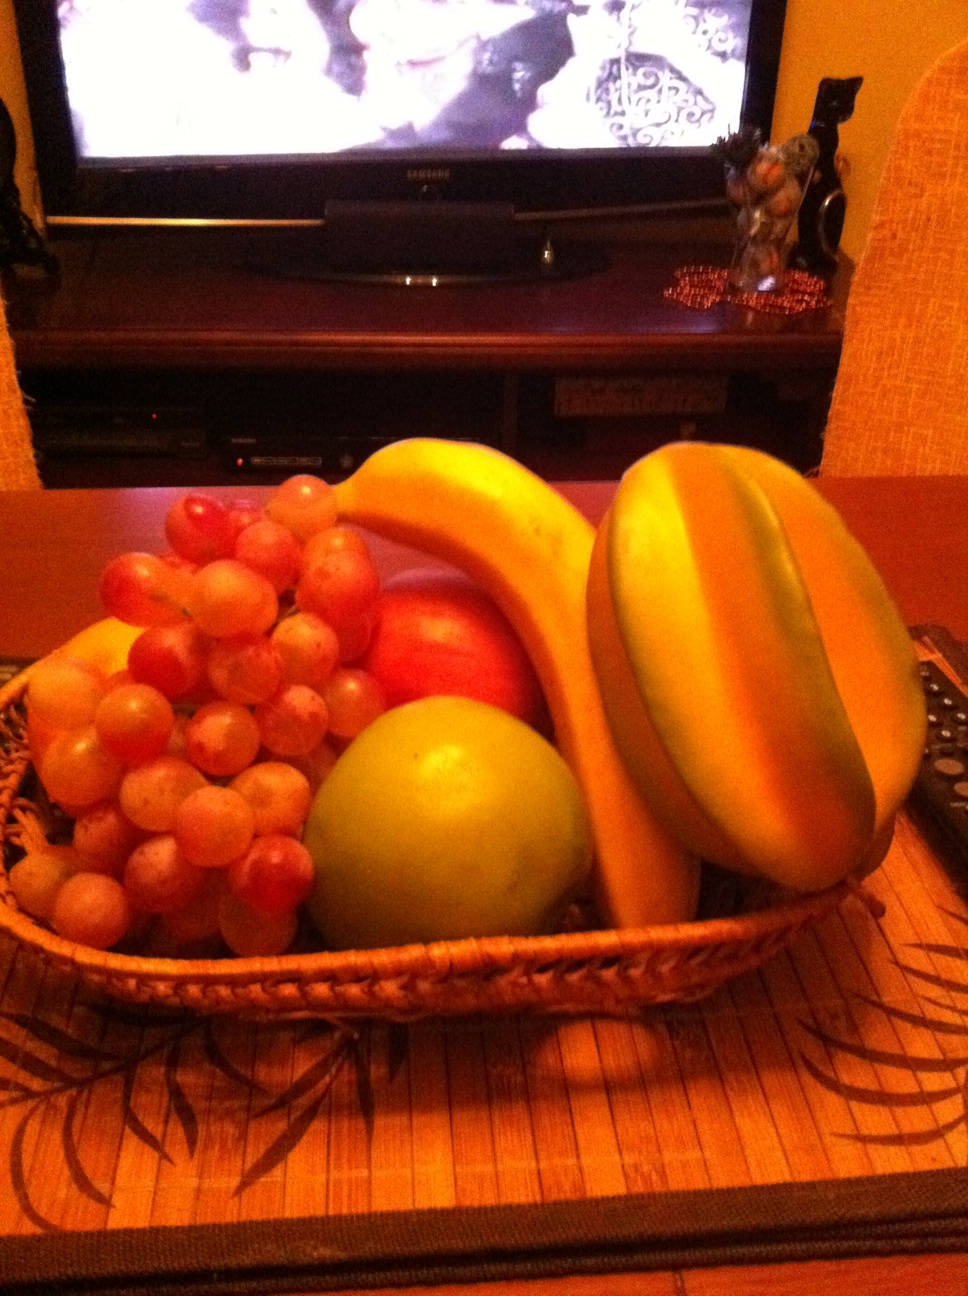What? What is this? from Vizwiz The image showcases a fruit basket containing a variety of fruits including bananas, grapes, apples, and what may be a papaya, all resting on a table with a textured placemat, placed against a background featuring what appears to be a television screen. 